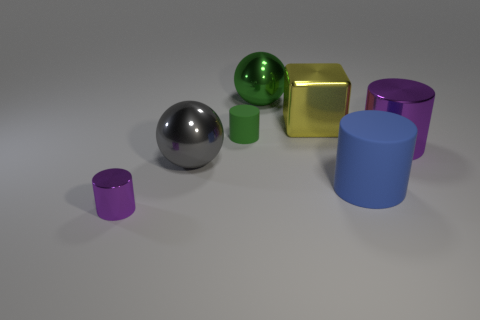There is a tiny green rubber object; is its shape the same as the big thing that is in front of the gray metal thing?
Ensure brevity in your answer.  Yes. The purple metallic object that is on the right side of the yellow object has what shape?
Keep it short and to the point. Cylinder. Is the yellow thing the same shape as the large purple metallic thing?
Your response must be concise. No. What is the size of the other metal thing that is the same shape as the big purple shiny object?
Offer a terse response. Small. There is a green thing in front of the green sphere; is it the same size as the large yellow cube?
Ensure brevity in your answer.  No. How big is the object that is in front of the cube and behind the big purple thing?
Your response must be concise. Small. What is the material of the ball that is the same color as the tiny rubber object?
Provide a short and direct response. Metal. How many metallic blocks are the same color as the small metal thing?
Provide a succinct answer. 0. Are there the same number of yellow things behind the shiny block and large gray things?
Provide a short and direct response. No. What is the color of the small shiny object?
Ensure brevity in your answer.  Purple. 